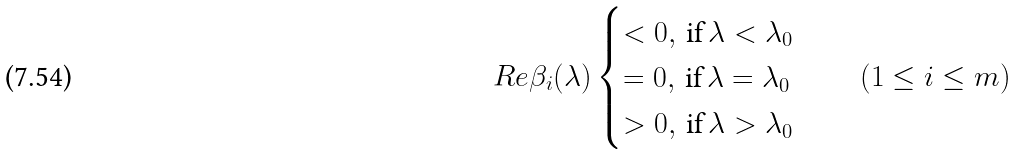Convert formula to latex. <formula><loc_0><loc_0><loc_500><loc_500>R e \beta _ { i } ( \lambda ) \begin{cases} < 0 , \, \text {if} \, \lambda < \lambda _ { 0 } \\ = 0 , \, \text {if} \, \lambda = \lambda _ { 0 } \\ > 0 , \, \text {if} \, \lambda > \lambda _ { 0 } \end{cases} \quad ( 1 \leq i \leq m )</formula> 